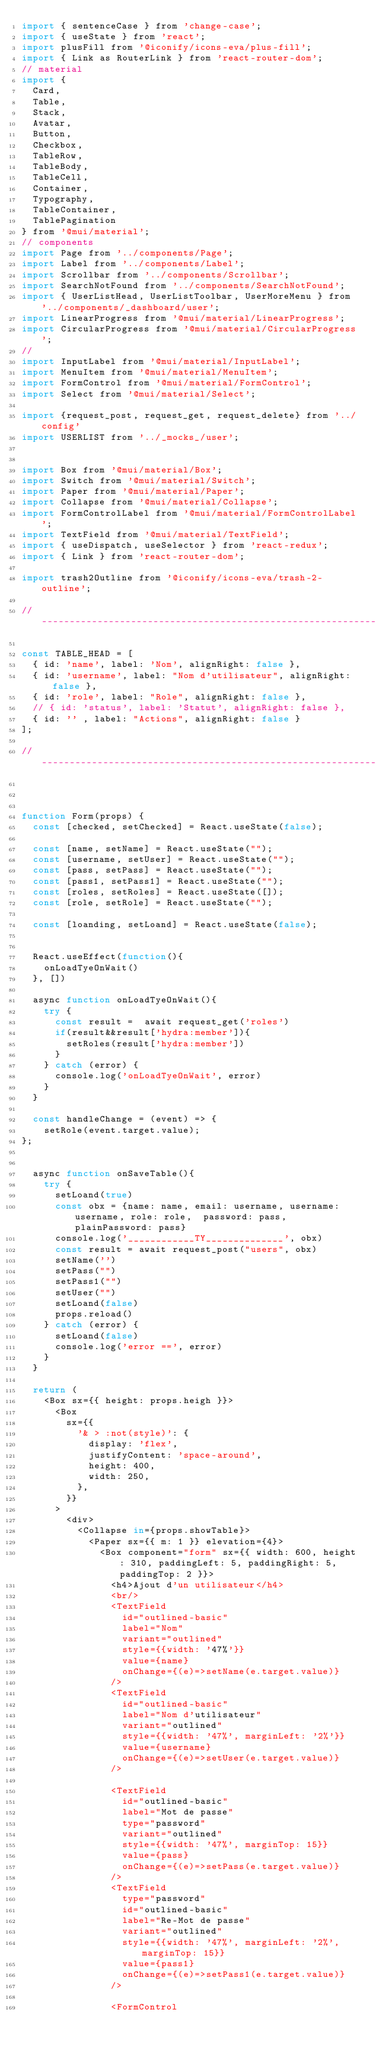Convert code to text. <code><loc_0><loc_0><loc_500><loc_500><_JavaScript_>import { sentenceCase } from 'change-case';
import { useState } from 'react';
import plusFill from '@iconify/icons-eva/plus-fill';
import { Link as RouterLink } from 'react-router-dom';
// material
import {
  Card,
  Table,
  Stack,
  Avatar,
  Button,
  Checkbox,
  TableRow,
  TableBody,
  TableCell,
  Container,
  Typography,
  TableContainer,
  TablePagination
} from '@mui/material';
// components
import Page from '../components/Page';
import Label from '../components/Label';
import Scrollbar from '../components/Scrollbar';
import SearchNotFound from '../components/SearchNotFound';
import { UserListHead, UserListToolbar, UserMoreMenu } from '../components/_dashboard/user';
import LinearProgress from '@mui/material/LinearProgress';
import CircularProgress from '@mui/material/CircularProgress';
//
import InputLabel from '@mui/material/InputLabel';
import MenuItem from '@mui/material/MenuItem';
import FormControl from '@mui/material/FormControl';
import Select from '@mui/material/Select';

import {request_post, request_get, request_delete} from '../config'
import USERLIST from '../_mocks_/user';


import Box from '@mui/material/Box';
import Switch from '@mui/material/Switch';
import Paper from '@mui/material/Paper';
import Collapse from '@mui/material/Collapse';
import FormControlLabel from '@mui/material/FormControlLabel';
import TextField from '@mui/material/TextField';
import { useDispatch, useSelector } from 'react-redux';
import { Link } from 'react-router-dom';

import trash2Outline from '@iconify/icons-eva/trash-2-outline';

// ----------------------------------------------------------------------

const TABLE_HEAD = [
  { id: 'name', label: 'Nom', alignRight: false },
  { id: 'username', label: "Nom d'utilisateur", alignRight: false },
  { id: 'role', label: "Role", alignRight: false },
  // { id: 'status', label: 'Statut', alignRight: false },
  { id: '' , label: "Actions", alignRight: false }
];

// ----------------------------------------------------------------------



function Form(props) {
  const [checked, setChecked] = React.useState(false);

  const [name, setName] = React.useState("");
  const [username, setUser] = React.useState("");
  const [pass, setPass] = React.useState("");
  const [pass1, setPass1] = React.useState("");
  const [roles, setRoles] = React.useState([]);
  const [role, setRole] = React.useState("");

  const [loanding, setLoand] = React.useState(false); 

  
  React.useEffect(function(){
    onLoadTyeOnWait()
  }, [])

  async function onLoadTyeOnWait(){
    try {
      const result =  await request_get('roles')
      if(result&&result['hydra:member']){
        setRoles(result['hydra:member'])
      }
    } catch (error) {
      console.log('onLoadTyeOnWait', error)
    }
  }

  const handleChange = (event) => {
    setRole(event.target.value);
};


  async function onSaveTable(){
    try {
      setLoand(true)
      const obx = {name: name, email: username, username: username, role: role,  password: pass, plainPassword: pass}
      console.log('____________TY______________', obx)
      const result = await request_post("users", obx)
      setName('')
      setPass("")
      setPass1("")
      setUser("")
      setLoand(false)
      props.reload()
    } catch (error) {
      setLoand(false)
      console.log('error ==', error)
    }
  }

  return (
    <Box sx={{ height: props.heigh }}>
      <Box
        sx={{
          '& > :not(style)': {
            display: 'flex',
            justifyContent: 'space-around',
            height: 400,
            width: 250,
          },
        }}
      >
        <div>
          <Collapse in={props.showTable}>
            <Paper sx={{ m: 1 }} elevation={4}>
              <Box component="form" sx={{ width: 600, height: 310, paddingLeft: 5, paddingRight: 5, paddingTop: 2 }}>
                <h4>Ajout d'un utilisateur</h4>
                <br/>
                <TextField 
                  id="outlined-basic" 
                  label="Nom" 
                  variant="outlined" 
                  style={{width: '47%'}} 
                  value={name}
                  onChange={(e)=>setName(e.target.value)}
                />
                <TextField 
                  id="outlined-basic" 
                  label="Nom d'utilisateur" 
                  variant="outlined" 
                  style={{width: '47%', marginLeft: '2%'}} 
                  value={username}
                  onChange={(e)=>setUser(e.target.value)}
                />

                <TextField 
                  id="outlined-basic" 
                  label="Mot de passe" 
                  type="password"
                  variant="outlined" 
                  style={{width: '47%', marginTop: 15}} 
                  value={pass}
                  onChange={(e)=>setPass(e.target.value)}
                />
                <TextField 
                  type="password"
                  id="outlined-basic" 
                  label="Re-Mot de passe" 
                  variant="outlined" 
                  style={{width: '47%', marginLeft: '2%', marginTop: 15}} 
                  value={pass1}
                  onChange={(e)=>setPass1(e.target.value)}
                />

                <FormControl</code> 